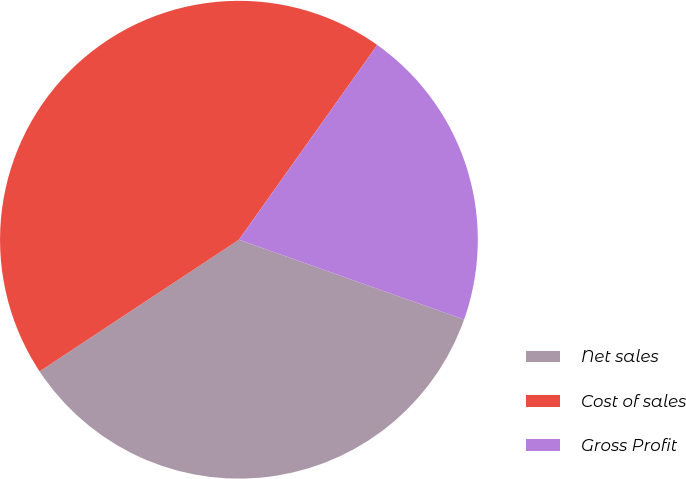Convert chart to OTSL. <chart><loc_0><loc_0><loc_500><loc_500><pie_chart><fcel>Net sales<fcel>Cost of sales<fcel>Gross Profit<nl><fcel>35.29%<fcel>44.12%<fcel>20.59%<nl></chart> 